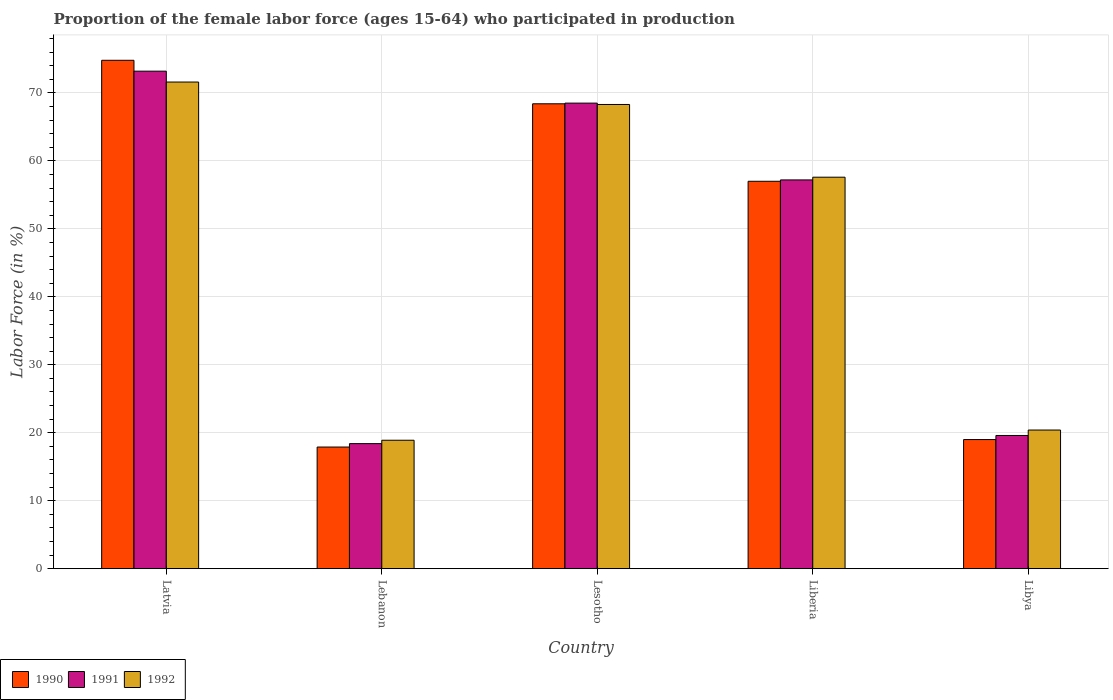How many different coloured bars are there?
Offer a terse response. 3. How many groups of bars are there?
Ensure brevity in your answer.  5. How many bars are there on the 2nd tick from the left?
Your answer should be compact. 3. How many bars are there on the 2nd tick from the right?
Ensure brevity in your answer.  3. What is the label of the 1st group of bars from the left?
Give a very brief answer. Latvia. What is the proportion of the female labor force who participated in production in 1991 in Lesotho?
Your response must be concise. 68.5. Across all countries, what is the maximum proportion of the female labor force who participated in production in 1990?
Offer a very short reply. 74.8. Across all countries, what is the minimum proportion of the female labor force who participated in production in 1990?
Ensure brevity in your answer.  17.9. In which country was the proportion of the female labor force who participated in production in 1990 maximum?
Keep it short and to the point. Latvia. In which country was the proportion of the female labor force who participated in production in 1991 minimum?
Keep it short and to the point. Lebanon. What is the total proportion of the female labor force who participated in production in 1991 in the graph?
Offer a very short reply. 236.9. What is the difference between the proportion of the female labor force who participated in production in 1990 in Libya and the proportion of the female labor force who participated in production in 1992 in Liberia?
Your answer should be very brief. -38.6. What is the average proportion of the female labor force who participated in production in 1990 per country?
Your answer should be very brief. 47.42. What is the difference between the proportion of the female labor force who participated in production of/in 1990 and proportion of the female labor force who participated in production of/in 1991 in Latvia?
Ensure brevity in your answer.  1.6. In how many countries, is the proportion of the female labor force who participated in production in 1992 greater than 44 %?
Your answer should be very brief. 3. What is the ratio of the proportion of the female labor force who participated in production in 1991 in Lebanon to that in Libya?
Your answer should be very brief. 0.94. Is the proportion of the female labor force who participated in production in 1991 in Latvia less than that in Liberia?
Your answer should be very brief. No. What is the difference between the highest and the second highest proportion of the female labor force who participated in production in 1991?
Offer a very short reply. 4.7. What is the difference between the highest and the lowest proportion of the female labor force who participated in production in 1990?
Offer a terse response. 56.9. In how many countries, is the proportion of the female labor force who participated in production in 1991 greater than the average proportion of the female labor force who participated in production in 1991 taken over all countries?
Your response must be concise. 3. Is the sum of the proportion of the female labor force who participated in production in 1992 in Lebanon and Lesotho greater than the maximum proportion of the female labor force who participated in production in 1991 across all countries?
Ensure brevity in your answer.  Yes. What is the difference between two consecutive major ticks on the Y-axis?
Your response must be concise. 10. What is the title of the graph?
Your answer should be very brief. Proportion of the female labor force (ages 15-64) who participated in production. Does "1970" appear as one of the legend labels in the graph?
Your answer should be very brief. No. What is the label or title of the X-axis?
Offer a very short reply. Country. What is the Labor Force (in %) in 1990 in Latvia?
Provide a succinct answer. 74.8. What is the Labor Force (in %) of 1991 in Latvia?
Provide a short and direct response. 73.2. What is the Labor Force (in %) of 1992 in Latvia?
Offer a very short reply. 71.6. What is the Labor Force (in %) in 1990 in Lebanon?
Give a very brief answer. 17.9. What is the Labor Force (in %) in 1991 in Lebanon?
Keep it short and to the point. 18.4. What is the Labor Force (in %) in 1992 in Lebanon?
Your response must be concise. 18.9. What is the Labor Force (in %) in 1990 in Lesotho?
Keep it short and to the point. 68.4. What is the Labor Force (in %) of 1991 in Lesotho?
Offer a very short reply. 68.5. What is the Labor Force (in %) in 1992 in Lesotho?
Make the answer very short. 68.3. What is the Labor Force (in %) of 1990 in Liberia?
Give a very brief answer. 57. What is the Labor Force (in %) of 1991 in Liberia?
Keep it short and to the point. 57.2. What is the Labor Force (in %) in 1992 in Liberia?
Your answer should be very brief. 57.6. What is the Labor Force (in %) in 1990 in Libya?
Ensure brevity in your answer.  19. What is the Labor Force (in %) of 1991 in Libya?
Keep it short and to the point. 19.6. What is the Labor Force (in %) of 1992 in Libya?
Your response must be concise. 20.4. Across all countries, what is the maximum Labor Force (in %) of 1990?
Provide a short and direct response. 74.8. Across all countries, what is the maximum Labor Force (in %) in 1991?
Provide a succinct answer. 73.2. Across all countries, what is the maximum Labor Force (in %) in 1992?
Offer a very short reply. 71.6. Across all countries, what is the minimum Labor Force (in %) of 1990?
Your answer should be very brief. 17.9. Across all countries, what is the minimum Labor Force (in %) in 1991?
Offer a very short reply. 18.4. Across all countries, what is the minimum Labor Force (in %) of 1992?
Your answer should be very brief. 18.9. What is the total Labor Force (in %) of 1990 in the graph?
Make the answer very short. 237.1. What is the total Labor Force (in %) of 1991 in the graph?
Your response must be concise. 236.9. What is the total Labor Force (in %) of 1992 in the graph?
Offer a very short reply. 236.8. What is the difference between the Labor Force (in %) of 1990 in Latvia and that in Lebanon?
Give a very brief answer. 56.9. What is the difference between the Labor Force (in %) of 1991 in Latvia and that in Lebanon?
Keep it short and to the point. 54.8. What is the difference between the Labor Force (in %) of 1992 in Latvia and that in Lebanon?
Your response must be concise. 52.7. What is the difference between the Labor Force (in %) in 1990 in Latvia and that in Lesotho?
Ensure brevity in your answer.  6.4. What is the difference between the Labor Force (in %) in 1991 in Latvia and that in Lesotho?
Make the answer very short. 4.7. What is the difference between the Labor Force (in %) of 1992 in Latvia and that in Lesotho?
Give a very brief answer. 3.3. What is the difference between the Labor Force (in %) in 1990 in Latvia and that in Libya?
Your answer should be very brief. 55.8. What is the difference between the Labor Force (in %) in 1991 in Latvia and that in Libya?
Give a very brief answer. 53.6. What is the difference between the Labor Force (in %) in 1992 in Latvia and that in Libya?
Your answer should be compact. 51.2. What is the difference between the Labor Force (in %) in 1990 in Lebanon and that in Lesotho?
Make the answer very short. -50.5. What is the difference between the Labor Force (in %) in 1991 in Lebanon and that in Lesotho?
Ensure brevity in your answer.  -50.1. What is the difference between the Labor Force (in %) of 1992 in Lebanon and that in Lesotho?
Offer a terse response. -49.4. What is the difference between the Labor Force (in %) in 1990 in Lebanon and that in Liberia?
Offer a very short reply. -39.1. What is the difference between the Labor Force (in %) of 1991 in Lebanon and that in Liberia?
Your answer should be compact. -38.8. What is the difference between the Labor Force (in %) of 1992 in Lebanon and that in Liberia?
Keep it short and to the point. -38.7. What is the difference between the Labor Force (in %) of 1990 in Lebanon and that in Libya?
Offer a terse response. -1.1. What is the difference between the Labor Force (in %) in 1991 in Lebanon and that in Libya?
Provide a succinct answer. -1.2. What is the difference between the Labor Force (in %) in 1991 in Lesotho and that in Liberia?
Your response must be concise. 11.3. What is the difference between the Labor Force (in %) of 1990 in Lesotho and that in Libya?
Your answer should be very brief. 49.4. What is the difference between the Labor Force (in %) in 1991 in Lesotho and that in Libya?
Your answer should be compact. 48.9. What is the difference between the Labor Force (in %) of 1992 in Lesotho and that in Libya?
Offer a very short reply. 47.9. What is the difference between the Labor Force (in %) in 1990 in Liberia and that in Libya?
Offer a terse response. 38. What is the difference between the Labor Force (in %) of 1991 in Liberia and that in Libya?
Provide a succinct answer. 37.6. What is the difference between the Labor Force (in %) in 1992 in Liberia and that in Libya?
Provide a short and direct response. 37.2. What is the difference between the Labor Force (in %) of 1990 in Latvia and the Labor Force (in %) of 1991 in Lebanon?
Your response must be concise. 56.4. What is the difference between the Labor Force (in %) in 1990 in Latvia and the Labor Force (in %) in 1992 in Lebanon?
Offer a very short reply. 55.9. What is the difference between the Labor Force (in %) of 1991 in Latvia and the Labor Force (in %) of 1992 in Lebanon?
Provide a succinct answer. 54.3. What is the difference between the Labor Force (in %) of 1990 in Latvia and the Labor Force (in %) of 1991 in Lesotho?
Offer a terse response. 6.3. What is the difference between the Labor Force (in %) in 1990 in Latvia and the Labor Force (in %) in 1992 in Lesotho?
Offer a terse response. 6.5. What is the difference between the Labor Force (in %) of 1990 in Latvia and the Labor Force (in %) of 1991 in Liberia?
Offer a terse response. 17.6. What is the difference between the Labor Force (in %) in 1990 in Latvia and the Labor Force (in %) in 1991 in Libya?
Make the answer very short. 55.2. What is the difference between the Labor Force (in %) in 1990 in Latvia and the Labor Force (in %) in 1992 in Libya?
Keep it short and to the point. 54.4. What is the difference between the Labor Force (in %) in 1991 in Latvia and the Labor Force (in %) in 1992 in Libya?
Keep it short and to the point. 52.8. What is the difference between the Labor Force (in %) in 1990 in Lebanon and the Labor Force (in %) in 1991 in Lesotho?
Offer a very short reply. -50.6. What is the difference between the Labor Force (in %) of 1990 in Lebanon and the Labor Force (in %) of 1992 in Lesotho?
Your answer should be very brief. -50.4. What is the difference between the Labor Force (in %) of 1991 in Lebanon and the Labor Force (in %) of 1992 in Lesotho?
Provide a short and direct response. -49.9. What is the difference between the Labor Force (in %) of 1990 in Lebanon and the Labor Force (in %) of 1991 in Liberia?
Keep it short and to the point. -39.3. What is the difference between the Labor Force (in %) in 1990 in Lebanon and the Labor Force (in %) in 1992 in Liberia?
Make the answer very short. -39.7. What is the difference between the Labor Force (in %) of 1991 in Lebanon and the Labor Force (in %) of 1992 in Liberia?
Provide a short and direct response. -39.2. What is the difference between the Labor Force (in %) in 1990 in Lebanon and the Labor Force (in %) in 1992 in Libya?
Your answer should be very brief. -2.5. What is the difference between the Labor Force (in %) in 1991 in Lebanon and the Labor Force (in %) in 1992 in Libya?
Make the answer very short. -2. What is the difference between the Labor Force (in %) of 1990 in Lesotho and the Labor Force (in %) of 1991 in Libya?
Offer a very short reply. 48.8. What is the difference between the Labor Force (in %) of 1990 in Lesotho and the Labor Force (in %) of 1992 in Libya?
Offer a very short reply. 48. What is the difference between the Labor Force (in %) in 1991 in Lesotho and the Labor Force (in %) in 1992 in Libya?
Your response must be concise. 48.1. What is the difference between the Labor Force (in %) in 1990 in Liberia and the Labor Force (in %) in 1991 in Libya?
Offer a terse response. 37.4. What is the difference between the Labor Force (in %) in 1990 in Liberia and the Labor Force (in %) in 1992 in Libya?
Your answer should be compact. 36.6. What is the difference between the Labor Force (in %) of 1991 in Liberia and the Labor Force (in %) of 1992 in Libya?
Offer a terse response. 36.8. What is the average Labor Force (in %) in 1990 per country?
Offer a very short reply. 47.42. What is the average Labor Force (in %) of 1991 per country?
Ensure brevity in your answer.  47.38. What is the average Labor Force (in %) in 1992 per country?
Give a very brief answer. 47.36. What is the difference between the Labor Force (in %) in 1990 and Labor Force (in %) in 1992 in Latvia?
Give a very brief answer. 3.2. What is the difference between the Labor Force (in %) in 1991 and Labor Force (in %) in 1992 in Latvia?
Make the answer very short. 1.6. What is the difference between the Labor Force (in %) of 1990 and Labor Force (in %) of 1991 in Lesotho?
Ensure brevity in your answer.  -0.1. What is the difference between the Labor Force (in %) in 1990 and Labor Force (in %) in 1992 in Liberia?
Offer a very short reply. -0.6. What is the difference between the Labor Force (in %) in 1991 and Labor Force (in %) in 1992 in Libya?
Give a very brief answer. -0.8. What is the ratio of the Labor Force (in %) in 1990 in Latvia to that in Lebanon?
Offer a terse response. 4.18. What is the ratio of the Labor Force (in %) of 1991 in Latvia to that in Lebanon?
Make the answer very short. 3.98. What is the ratio of the Labor Force (in %) in 1992 in Latvia to that in Lebanon?
Provide a succinct answer. 3.79. What is the ratio of the Labor Force (in %) in 1990 in Latvia to that in Lesotho?
Provide a short and direct response. 1.09. What is the ratio of the Labor Force (in %) of 1991 in Latvia to that in Lesotho?
Your answer should be very brief. 1.07. What is the ratio of the Labor Force (in %) of 1992 in Latvia to that in Lesotho?
Ensure brevity in your answer.  1.05. What is the ratio of the Labor Force (in %) of 1990 in Latvia to that in Liberia?
Provide a short and direct response. 1.31. What is the ratio of the Labor Force (in %) of 1991 in Latvia to that in Liberia?
Your response must be concise. 1.28. What is the ratio of the Labor Force (in %) in 1992 in Latvia to that in Liberia?
Offer a terse response. 1.24. What is the ratio of the Labor Force (in %) of 1990 in Latvia to that in Libya?
Your answer should be very brief. 3.94. What is the ratio of the Labor Force (in %) in 1991 in Latvia to that in Libya?
Give a very brief answer. 3.73. What is the ratio of the Labor Force (in %) of 1992 in Latvia to that in Libya?
Your answer should be very brief. 3.51. What is the ratio of the Labor Force (in %) of 1990 in Lebanon to that in Lesotho?
Your answer should be very brief. 0.26. What is the ratio of the Labor Force (in %) in 1991 in Lebanon to that in Lesotho?
Keep it short and to the point. 0.27. What is the ratio of the Labor Force (in %) in 1992 in Lebanon to that in Lesotho?
Provide a short and direct response. 0.28. What is the ratio of the Labor Force (in %) of 1990 in Lebanon to that in Liberia?
Make the answer very short. 0.31. What is the ratio of the Labor Force (in %) in 1991 in Lebanon to that in Liberia?
Give a very brief answer. 0.32. What is the ratio of the Labor Force (in %) in 1992 in Lebanon to that in Liberia?
Offer a terse response. 0.33. What is the ratio of the Labor Force (in %) in 1990 in Lebanon to that in Libya?
Ensure brevity in your answer.  0.94. What is the ratio of the Labor Force (in %) in 1991 in Lebanon to that in Libya?
Provide a short and direct response. 0.94. What is the ratio of the Labor Force (in %) in 1992 in Lebanon to that in Libya?
Keep it short and to the point. 0.93. What is the ratio of the Labor Force (in %) in 1991 in Lesotho to that in Liberia?
Make the answer very short. 1.2. What is the ratio of the Labor Force (in %) of 1992 in Lesotho to that in Liberia?
Offer a terse response. 1.19. What is the ratio of the Labor Force (in %) in 1991 in Lesotho to that in Libya?
Keep it short and to the point. 3.49. What is the ratio of the Labor Force (in %) in 1992 in Lesotho to that in Libya?
Give a very brief answer. 3.35. What is the ratio of the Labor Force (in %) in 1990 in Liberia to that in Libya?
Your answer should be very brief. 3. What is the ratio of the Labor Force (in %) of 1991 in Liberia to that in Libya?
Offer a very short reply. 2.92. What is the ratio of the Labor Force (in %) of 1992 in Liberia to that in Libya?
Your answer should be compact. 2.82. What is the difference between the highest and the second highest Labor Force (in %) of 1990?
Provide a short and direct response. 6.4. What is the difference between the highest and the lowest Labor Force (in %) in 1990?
Keep it short and to the point. 56.9. What is the difference between the highest and the lowest Labor Force (in %) of 1991?
Offer a very short reply. 54.8. What is the difference between the highest and the lowest Labor Force (in %) in 1992?
Your answer should be very brief. 52.7. 